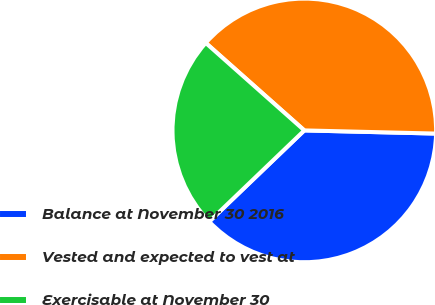Convert chart. <chart><loc_0><loc_0><loc_500><loc_500><pie_chart><fcel>Balance at November 30 2016<fcel>Vested and expected to vest at<fcel>Exercisable at November 30<nl><fcel>37.45%<fcel>38.83%<fcel>23.72%<nl></chart> 